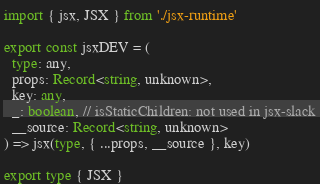<code> <loc_0><loc_0><loc_500><loc_500><_TypeScript_>import { jsx, JSX } from './jsx-runtime'

export const jsxDEV = (
  type: any,
  props: Record<string, unknown>,
  key: any,
  _: boolean, // isStaticChildren: not used in jsx-slack
  __source: Record<string, unknown>
) => jsx(type, { ...props, __source }, key)

export type { JSX }
</code> 